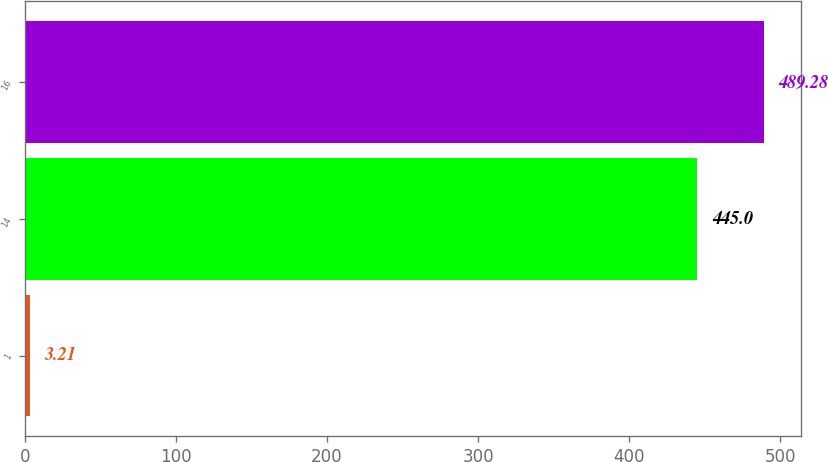Convert chart. <chart><loc_0><loc_0><loc_500><loc_500><bar_chart><fcel>1<fcel>14<fcel>16<nl><fcel>3.21<fcel>445<fcel>489.28<nl></chart> 